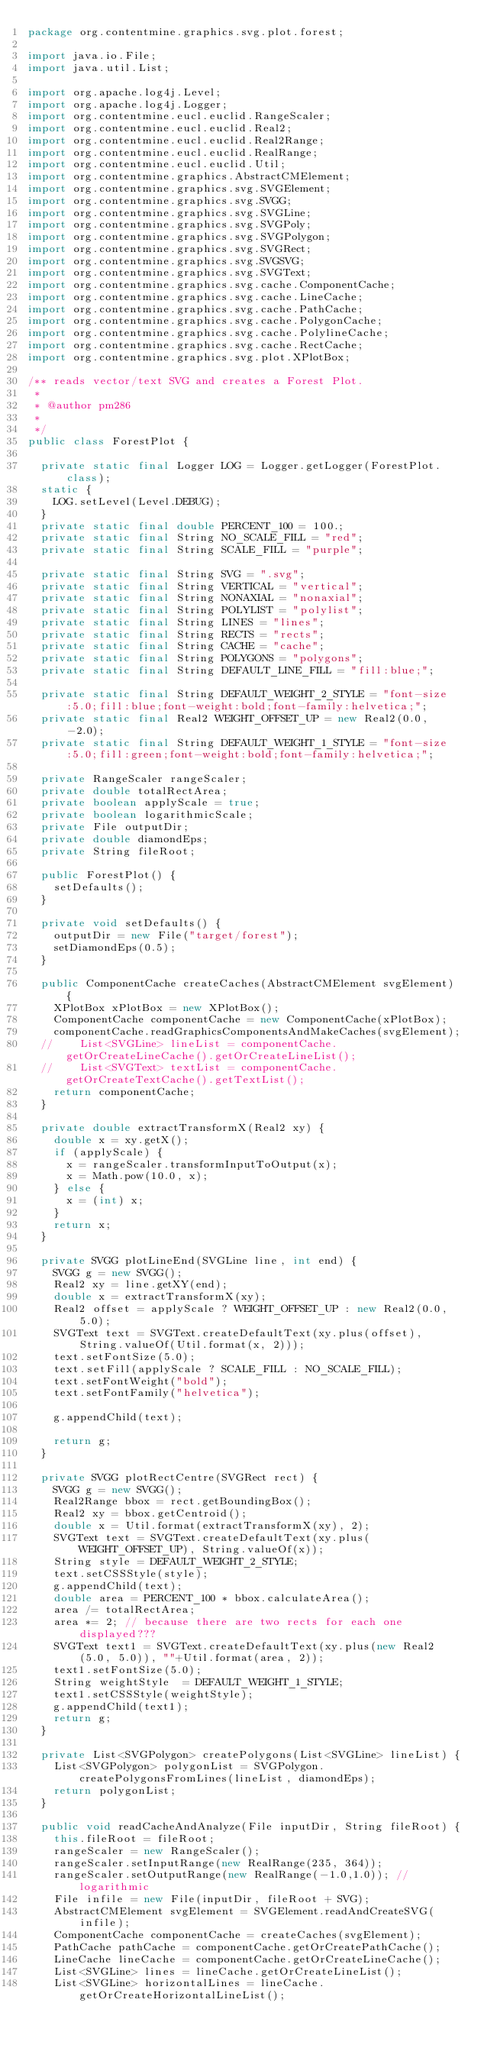<code> <loc_0><loc_0><loc_500><loc_500><_Java_>package org.contentmine.graphics.svg.plot.forest;

import java.io.File;
import java.util.List;

import org.apache.log4j.Level;
import org.apache.log4j.Logger;
import org.contentmine.eucl.euclid.RangeScaler;
import org.contentmine.eucl.euclid.Real2;
import org.contentmine.eucl.euclid.Real2Range;
import org.contentmine.eucl.euclid.RealRange;
import org.contentmine.eucl.euclid.Util;
import org.contentmine.graphics.AbstractCMElement;
import org.contentmine.graphics.svg.SVGElement;
import org.contentmine.graphics.svg.SVGG;
import org.contentmine.graphics.svg.SVGLine;
import org.contentmine.graphics.svg.SVGPoly;
import org.contentmine.graphics.svg.SVGPolygon;
import org.contentmine.graphics.svg.SVGRect;
import org.contentmine.graphics.svg.SVGSVG;
import org.contentmine.graphics.svg.SVGText;
import org.contentmine.graphics.svg.cache.ComponentCache;
import org.contentmine.graphics.svg.cache.LineCache;
import org.contentmine.graphics.svg.cache.PathCache;
import org.contentmine.graphics.svg.cache.PolygonCache;
import org.contentmine.graphics.svg.cache.PolylineCache;
import org.contentmine.graphics.svg.cache.RectCache;
import org.contentmine.graphics.svg.plot.XPlotBox;

/** reads vector/text SVG and creates a Forest Plot.
 * 
 * @author pm286
 *
 */
public class ForestPlot {

	private static final Logger LOG = Logger.getLogger(ForestPlot.class);
	static {
		LOG.setLevel(Level.DEBUG);
	}
	private static final double PERCENT_100 = 100.;
	private static final String NO_SCALE_FILL = "red";
	private static final String SCALE_FILL = "purple";
	
	private static final String SVG = ".svg";
	private static final String VERTICAL = "vertical";
	private static final String NONAXIAL = "nonaxial";
	private static final String POLYLIST = "polylist";
	private static final String LINES = "lines";
	private static final String RECTS = "rects";
	private static final String CACHE = "cache";
	private static final String POLYGONS = "polygons";
	private static final String DEFAULT_LINE_FILL = "fill:blue;";
	
	private static final String DEFAULT_WEIGHT_2_STYLE = "font-size:5.0;fill:blue;font-weight:bold;font-family:helvetica;";
	private static final Real2 WEIGHT_OFFSET_UP = new Real2(0.0, -2.0);
	private static final String DEFAULT_WEIGHT_1_STYLE = "font-size:5.0;fill:green;font-weight:bold;font-family:helvetica;";

	private RangeScaler rangeScaler;
	private double totalRectArea;
	private boolean applyScale = true;
	private boolean logarithmicScale;
	private File outputDir;
	private double diamondEps;
	private String fileRoot;
	
	public ForestPlot() {
		setDefaults();
	}

	private void setDefaults() {
		outputDir = new File("target/forest");
		setDiamondEps(0.5);
	}

	public ComponentCache createCaches(AbstractCMElement svgElement) {
		XPlotBox xPlotBox = new XPlotBox();
		ComponentCache componentCache = new ComponentCache(xPlotBox); 
		componentCache.readGraphicsComponentsAndMakeCaches(svgElement);
	//		List<SVGLine> lineList = componentCache.getOrCreateLineCache().getOrCreateLineList();
	//		List<SVGText> textList = componentCache.getOrCreateTextCache().getTextList();
		return componentCache;
	}

	private double extractTransformX(Real2 xy) {
		double x = xy.getX();
		if (applyScale) {
			x = rangeScaler.transformInputToOutput(x);
			x = Math.pow(10.0, x);
		} else {
			x = (int) x;
		}
		return x;
	}

	private SVGG plotLineEnd(SVGLine line, int end) {
		SVGG g = new SVGG();
		Real2 xy = line.getXY(end);
		double x = extractTransformX(xy);
		Real2 offset = applyScale ? WEIGHT_OFFSET_UP : new Real2(0.0, 5.0);
		SVGText text = SVGText.createDefaultText(xy.plus(offset), String.valueOf(Util.format(x, 2)));
		text.setFontSize(5.0);
		text.setFill(applyScale ? SCALE_FILL : NO_SCALE_FILL);
		text.setFontWeight("bold");
		text.setFontFamily("helvetica");
		
		g.appendChild(text);
		
		return g;
	}

	private SVGG plotRectCentre(SVGRect rect) {
		SVGG g = new SVGG();
		Real2Range bbox = rect.getBoundingBox();
		Real2 xy = bbox.getCentroid();
		double x = Util.format(extractTransformX(xy), 2);
		SVGText text = SVGText.createDefaultText(xy.plus(WEIGHT_OFFSET_UP), String.valueOf(x));
		String style = DEFAULT_WEIGHT_2_STYLE;
		text.setCSSStyle(style);
		g.appendChild(text);
		double area = PERCENT_100 * bbox.calculateArea();
		area /= totalRectArea;
		area *= 2; // because there are two rects for each one displayed???
		SVGText text1 = SVGText.createDefaultText(xy.plus(new Real2(5.0, 5.0)), ""+Util.format(area, 2));
		text1.setFontSize(5.0);
		String weightStyle  = DEFAULT_WEIGHT_1_STYLE;
		text1.setCSSStyle(weightStyle);
		g.appendChild(text1);
		return g;
	}

	private List<SVGPolygon> createPolygons(List<SVGLine> lineList) {
		List<SVGPolygon> polygonList = SVGPolygon.createPolygonsFromLines(lineList, diamondEps);
		return polygonList;
	}

	public void readCacheAndAnalyze(File inputDir, String fileRoot) {
		this.fileRoot = fileRoot;
		rangeScaler = new RangeScaler();
		rangeScaler.setInputRange(new RealRange(235, 364));
		rangeScaler.setOutputRange(new RealRange(-1.0,1.0)); // logarithmic
		File infile = new File(inputDir, fileRoot + SVG);
		AbstractCMElement svgElement = SVGElement.readAndCreateSVG(infile);
		ComponentCache componentCache = createCaches(svgElement);
		PathCache pathCache = componentCache.getOrCreatePathCache();
		LineCache lineCache = componentCache.getOrCreateLineCache();
		List<SVGLine> lines = lineCache.getOrCreateLineList();
		List<SVGLine> horizontalLines = lineCache.getOrCreateHorizontalLineList();</code> 